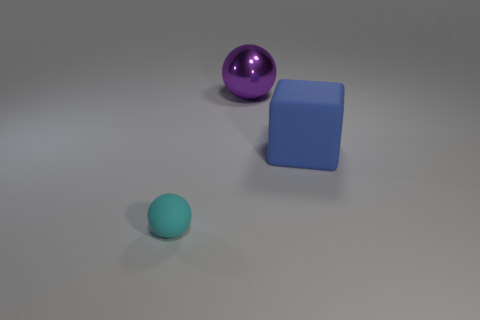Add 1 large blue things. How many objects exist? 4 Subtract all blocks. How many objects are left? 2 Subtract all small yellow rubber cubes. Subtract all blue cubes. How many objects are left? 2 Add 1 big metallic objects. How many big metallic objects are left? 2 Add 2 large blue rubber blocks. How many large blue rubber blocks exist? 3 Subtract 0 cyan cubes. How many objects are left? 3 